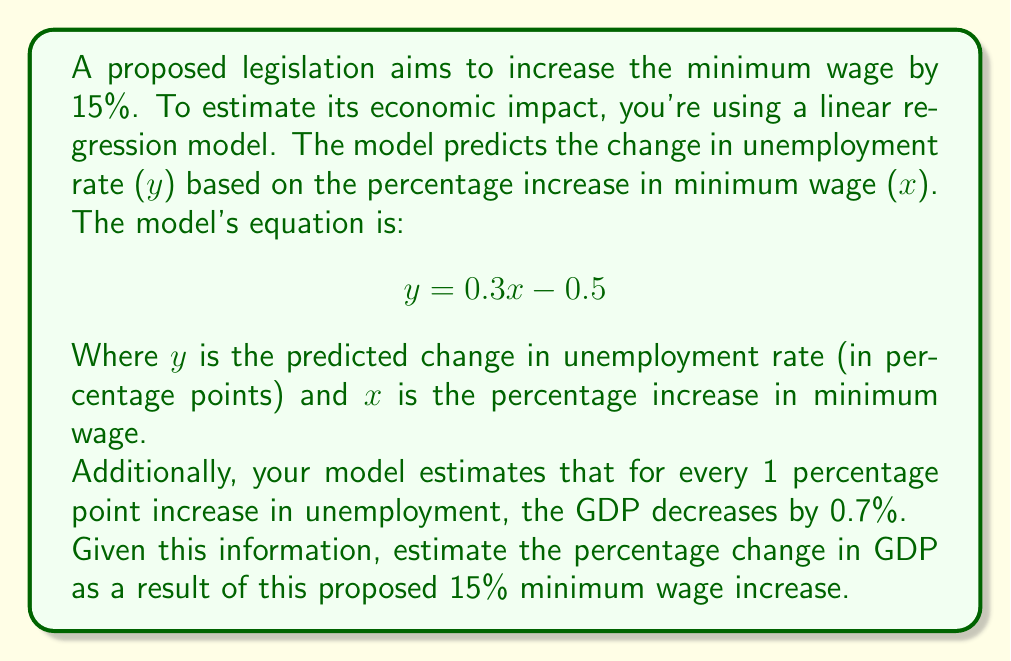Provide a solution to this math problem. To solve this problem, we'll follow these steps:

1. Calculate the predicted change in unemployment rate:
   We know x = 15 (15% increase in minimum wage)
   $$ y = 0.3x - 0.5 $$
   $$ y = 0.3(15) - 0.5 $$
   $$ y = 4.5 - 0.5 = 4 $$
   So, the predicted change in unemployment rate is 4 percentage points.

2. Calculate the impact on GDP:
   We're told that for every 1 percentage point increase in unemployment, GDP decreases by 0.7%.
   So, for a 4 percentage point increase, we multiply:
   $$ \text{GDP change} = 4 \times (-0.7\%) = -2.8\% $$

Therefore, the model predicts that the GDP would decrease by 2.8% as a result of the proposed 15% minimum wage increase.
Answer: -2.8% 